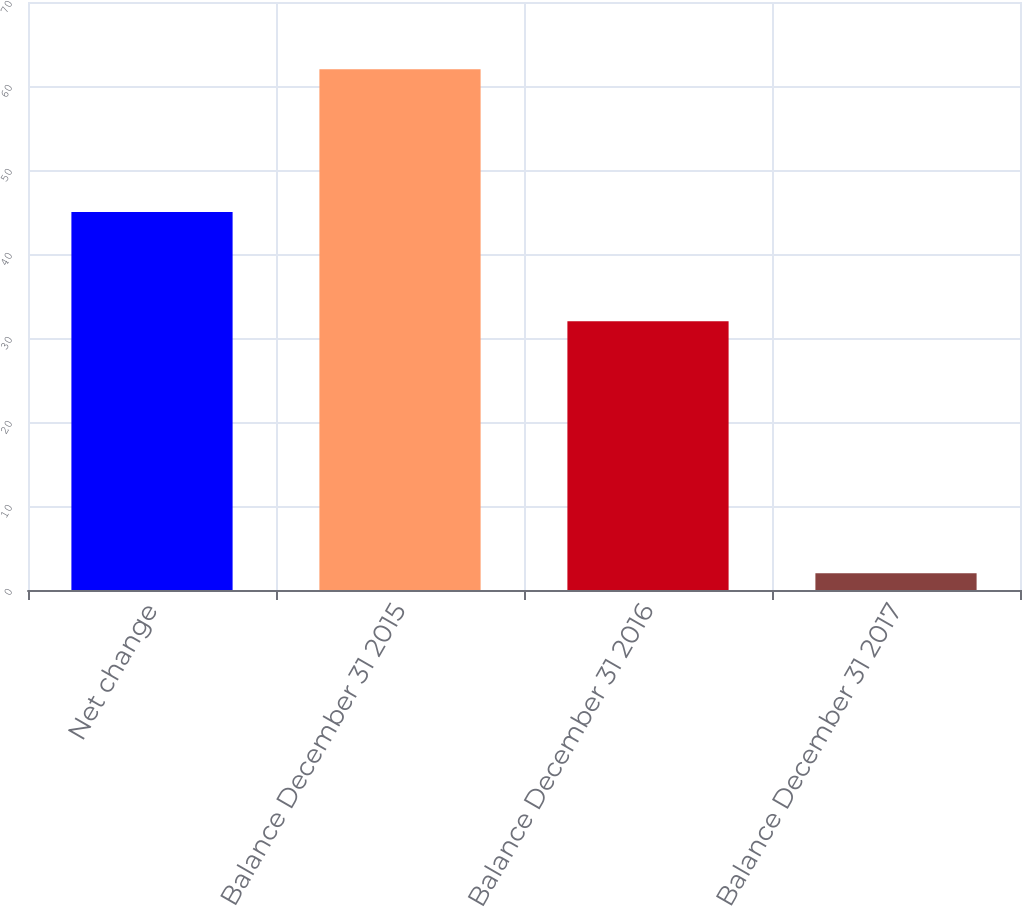Convert chart to OTSL. <chart><loc_0><loc_0><loc_500><loc_500><bar_chart><fcel>Net change<fcel>Balance December 31 2015<fcel>Balance December 31 2016<fcel>Balance December 31 2017<nl><fcel>45<fcel>62<fcel>32<fcel>2<nl></chart> 